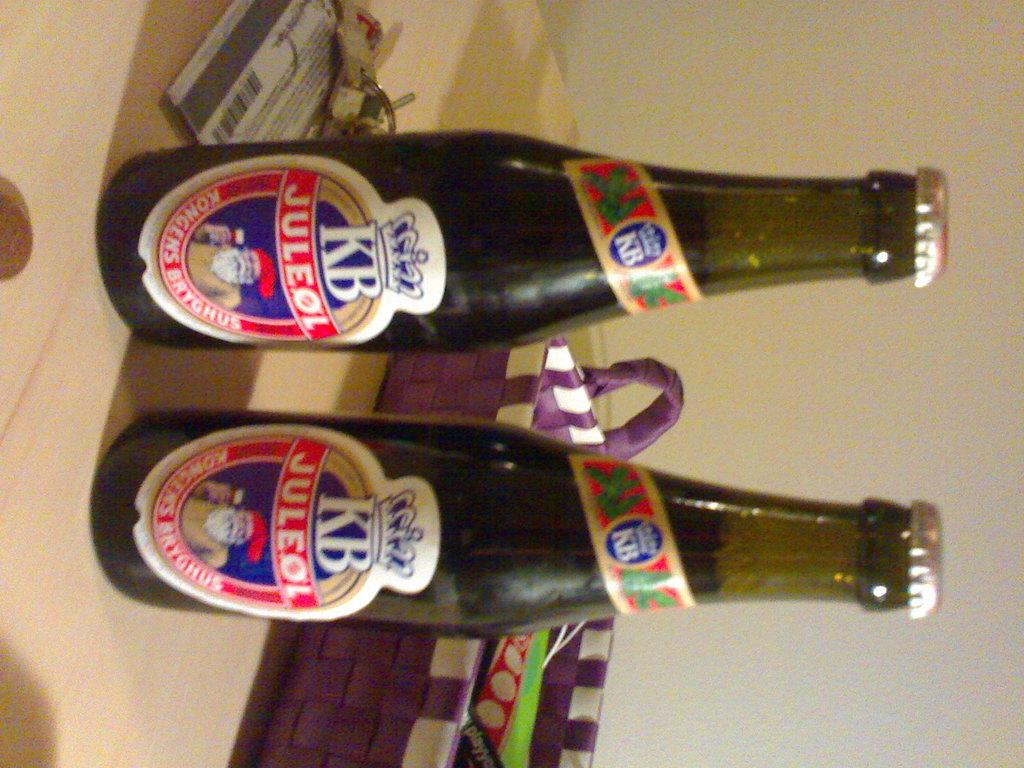<image>
Write a terse but informative summary of the picture. 2 new bottle sof kb juleol beer sit on the counter 